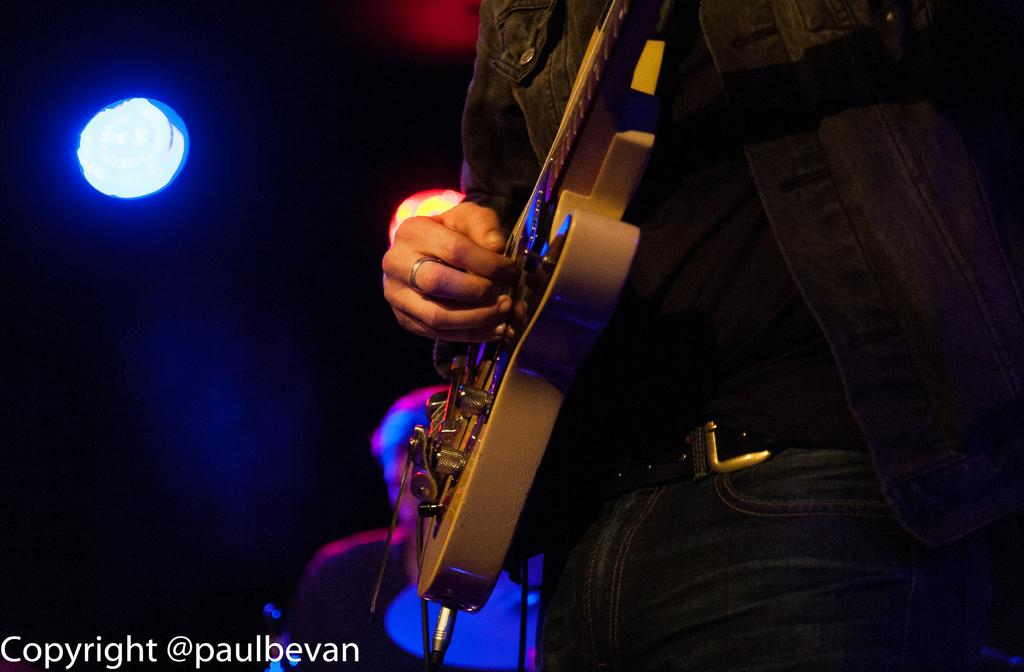What is the person in the image doing? The person is playing a guitar. Can you describe the lighting in the image? There is a light in the background of the image. Is there any text or marking at the bottom of the image? Yes, there is a watermark at the bottom of the image. What type of hook is the person using to play the guitar in the image? There is no hook present in the image; the person is playing the guitar with their hands. 